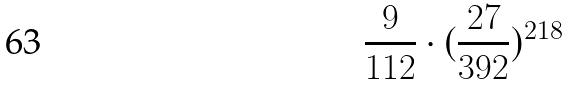<formula> <loc_0><loc_0><loc_500><loc_500>\frac { 9 } { 1 1 2 } \cdot ( \frac { 2 7 } { 3 9 2 } ) ^ { 2 1 8 }</formula> 